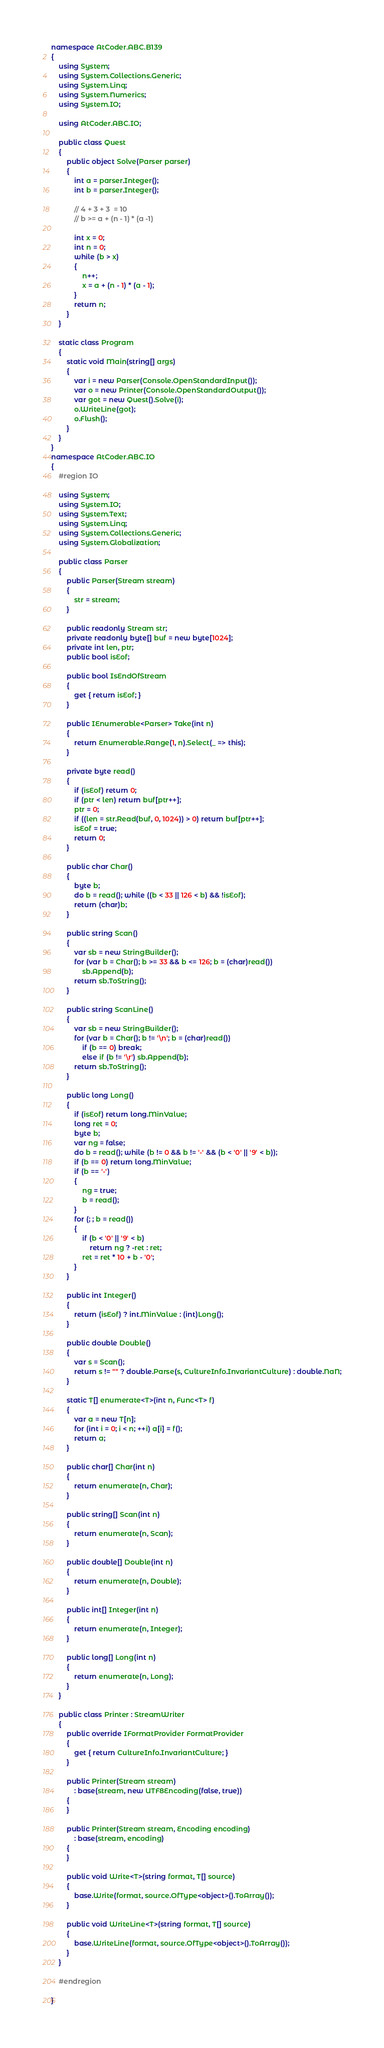<code> <loc_0><loc_0><loc_500><loc_500><_C#_>namespace AtCoder.ABC.B139
{
    using System;
    using System.Collections.Generic;
    using System.Linq;
    using System.Numerics;
    using System.IO;

    using AtCoder.ABC.IO;

    public class Quest
    {
        public object Solve(Parser parser)
        {
            int a = parser.Integer();
            int b = parser.Integer();

            // 4 + 3 + 3  = 10
            // b >= a + (n - 1) * (a -1)

            int x = 0;
            int n = 0;
            while (b > x)
            {
                n++;
                x = a + (n - 1) * (a - 1);
            }
            return n;
        }
    }

    static class Program
    {
        static void Main(string[] args)
        {
            var i = new Parser(Console.OpenStandardInput());
            var o = new Printer(Console.OpenStandardOutput());
            var got = new Quest().Solve(i);
            o.WriteLine(got);
            o.Flush();
        }
    }
}
namespace AtCoder.ABC.IO
{
    #region IO

    using System;
    using System.IO;
    using System.Text;
    using System.Linq;
    using System.Collections.Generic;
    using System.Globalization;

    public class Parser
    {
        public Parser(Stream stream)
        {
            str = stream;
        }

        public readonly Stream str;
        private readonly byte[] buf = new byte[1024];
        private int len, ptr;
        public bool isEof;

        public bool IsEndOfStream
        {
            get { return isEof; }
        }

        public IEnumerable<Parser> Take(int n)
        {
            return Enumerable.Range(1, n).Select(_ => this);
        }

        private byte read()
        {
            if (isEof) return 0;
            if (ptr < len) return buf[ptr++];
            ptr = 0;
            if ((len = str.Read(buf, 0, 1024)) > 0) return buf[ptr++];
            isEof = true;
            return 0;
        }

        public char Char()
        {
            byte b;
            do b = read(); while ((b < 33 || 126 < b) && !isEof);
            return (char)b;
        }

        public string Scan()
        {
            var sb = new StringBuilder();
            for (var b = Char(); b >= 33 && b <= 126; b = (char)read())
                sb.Append(b);
            return sb.ToString();
        }

        public string ScanLine()
        {
            var sb = new StringBuilder();
            for (var b = Char(); b != '\n'; b = (char)read())
                if (b == 0) break;
                else if (b != '\r') sb.Append(b);
            return sb.ToString();
        }

        public long Long()
        {
            if (isEof) return long.MinValue;
            long ret = 0;
            byte b;
            var ng = false;
            do b = read(); while (b != 0 && b != '-' && (b < '0' || '9' < b));
            if (b == 0) return long.MinValue;
            if (b == '-')
            {
                ng = true;
                b = read();
            }
            for (; ; b = read())
            {
                if (b < '0' || '9' < b)
                    return ng ? -ret : ret;
                ret = ret * 10 + b - '0';
            }
        }

        public int Integer()
        {
            return (isEof) ? int.MinValue : (int)Long();
        }

        public double Double()
        {
            var s = Scan();
            return s != "" ? double.Parse(s, CultureInfo.InvariantCulture) : double.NaN;
        }

        static T[] enumerate<T>(int n, Func<T> f)
        {
            var a = new T[n];
            for (int i = 0; i < n; ++i) a[i] = f();
            return a;
        }

        public char[] Char(int n)
        {
            return enumerate(n, Char);
        }

        public string[] Scan(int n)
        {
            return enumerate(n, Scan);
        }

        public double[] Double(int n)
        {
            return enumerate(n, Double);
        }

        public int[] Integer(int n)
        {
            return enumerate(n, Integer);
        }

        public long[] Long(int n)
        {
            return enumerate(n, Long);
        }
    }

    public class Printer : StreamWriter
    {
        public override IFormatProvider FormatProvider
        {
            get { return CultureInfo.InvariantCulture; }
        }

        public Printer(Stream stream)
            : base(stream, new UTF8Encoding(false, true))
        {
        }

        public Printer(Stream stream, Encoding encoding)
            : base(stream, encoding)
        {
        }

        public void Write<T>(string format, T[] source)
        {
            base.Write(format, source.OfType<object>().ToArray());
        }

        public void WriteLine<T>(string format, T[] source)
        {
            base.WriteLine(format, source.OfType<object>().ToArray());
        }
    }

    #endregion

}</code> 